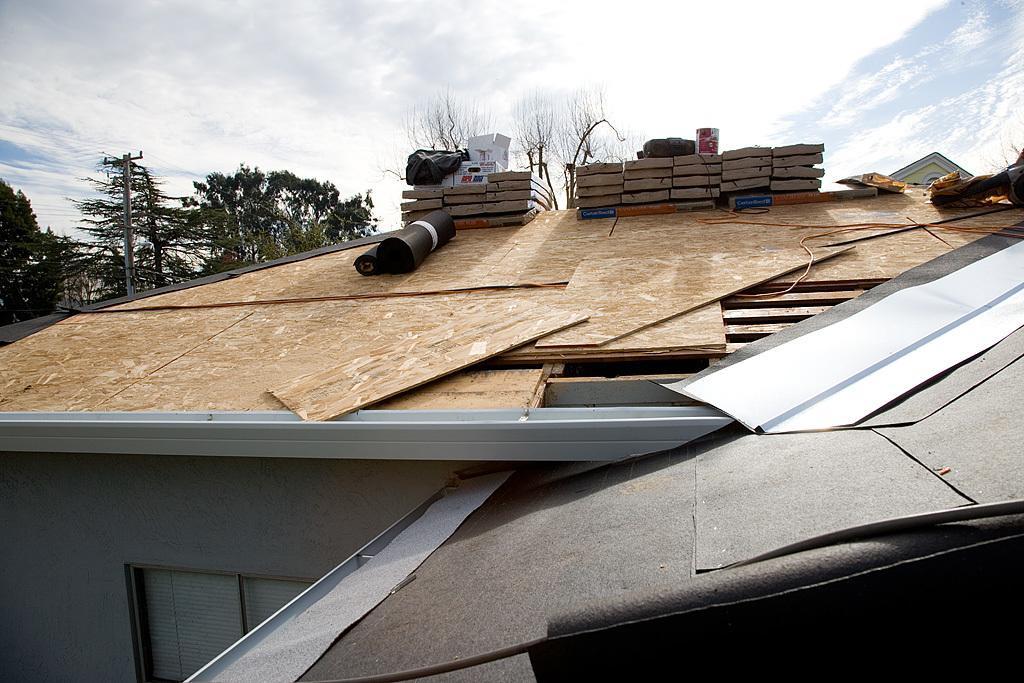Describe this image in one or two sentences. In this image we can see wooden planks, containers and rolled mats. In the background there are sky with clouds, trees, electric poles and electric cables. 